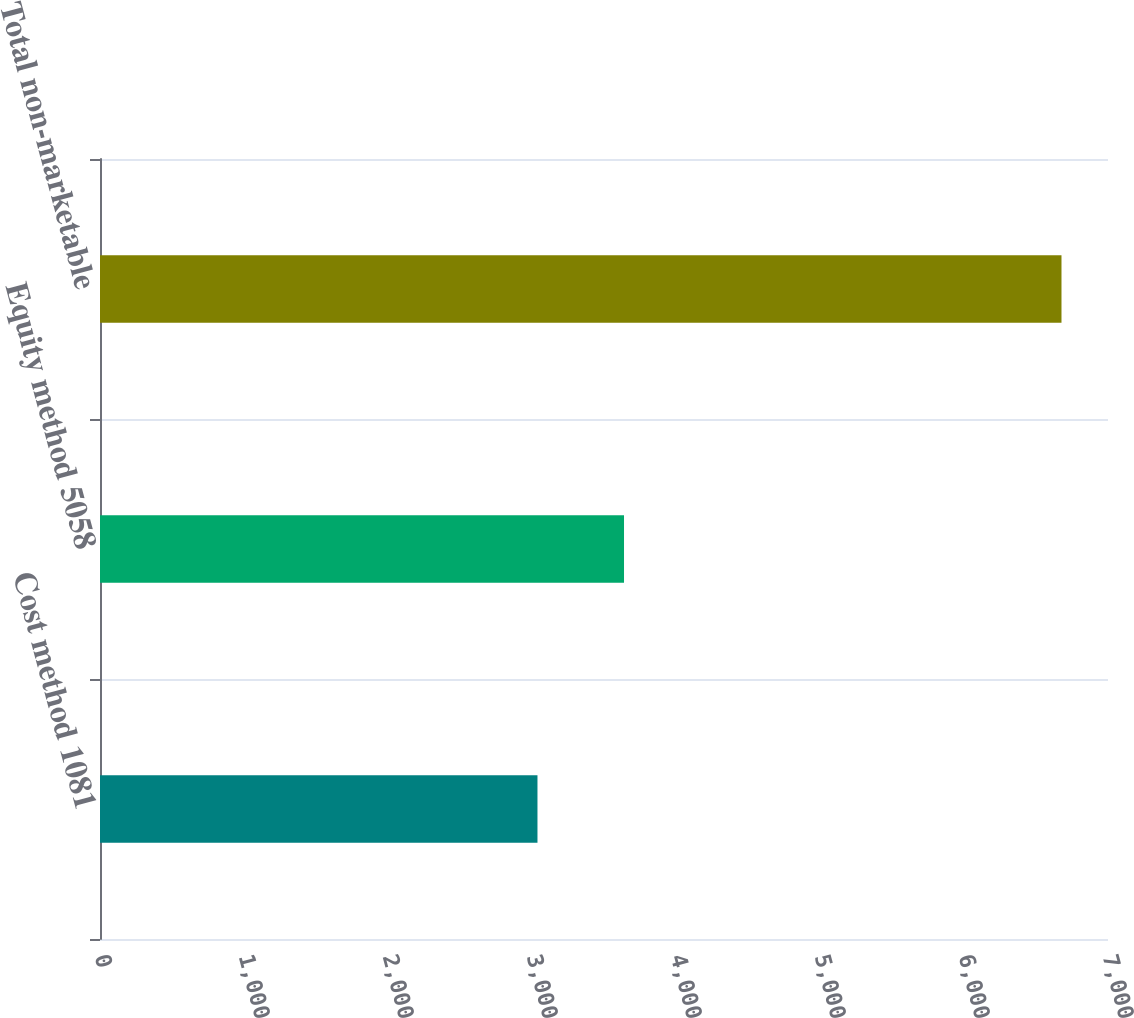<chart> <loc_0><loc_0><loc_500><loc_500><bar_chart><fcel>Cost method 1081<fcel>Equity method 5058<fcel>Total non-marketable<nl><fcel>3038<fcel>3639<fcel>6677<nl></chart> 